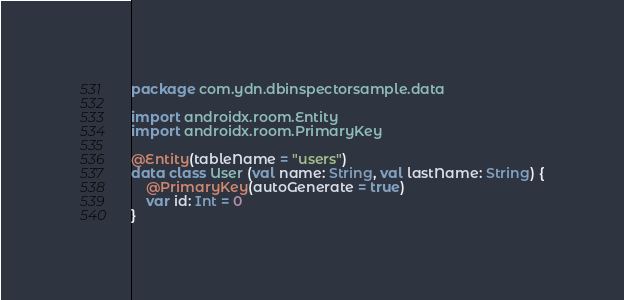<code> <loc_0><loc_0><loc_500><loc_500><_Kotlin_>package com.ydn.dbinspectorsample.data

import androidx.room.Entity
import androidx.room.PrimaryKey

@Entity(tableName = "users")
data class User (val name: String, val lastName: String) {
    @PrimaryKey(autoGenerate = true)
    var id: Int = 0
}</code> 